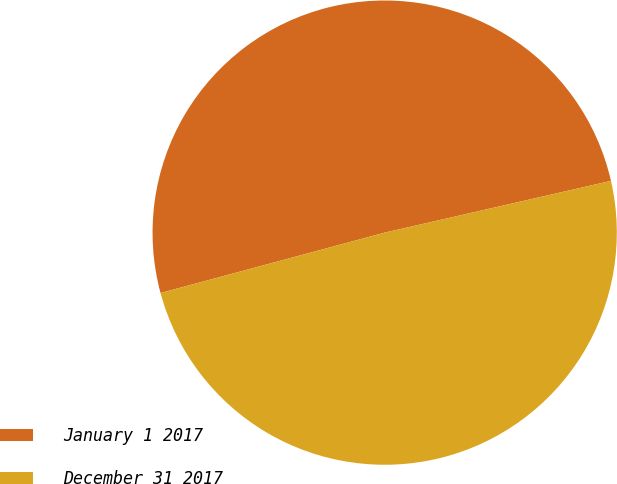<chart> <loc_0><loc_0><loc_500><loc_500><pie_chart><fcel>January 1 2017<fcel>December 31 2017<nl><fcel>50.61%<fcel>49.39%<nl></chart> 